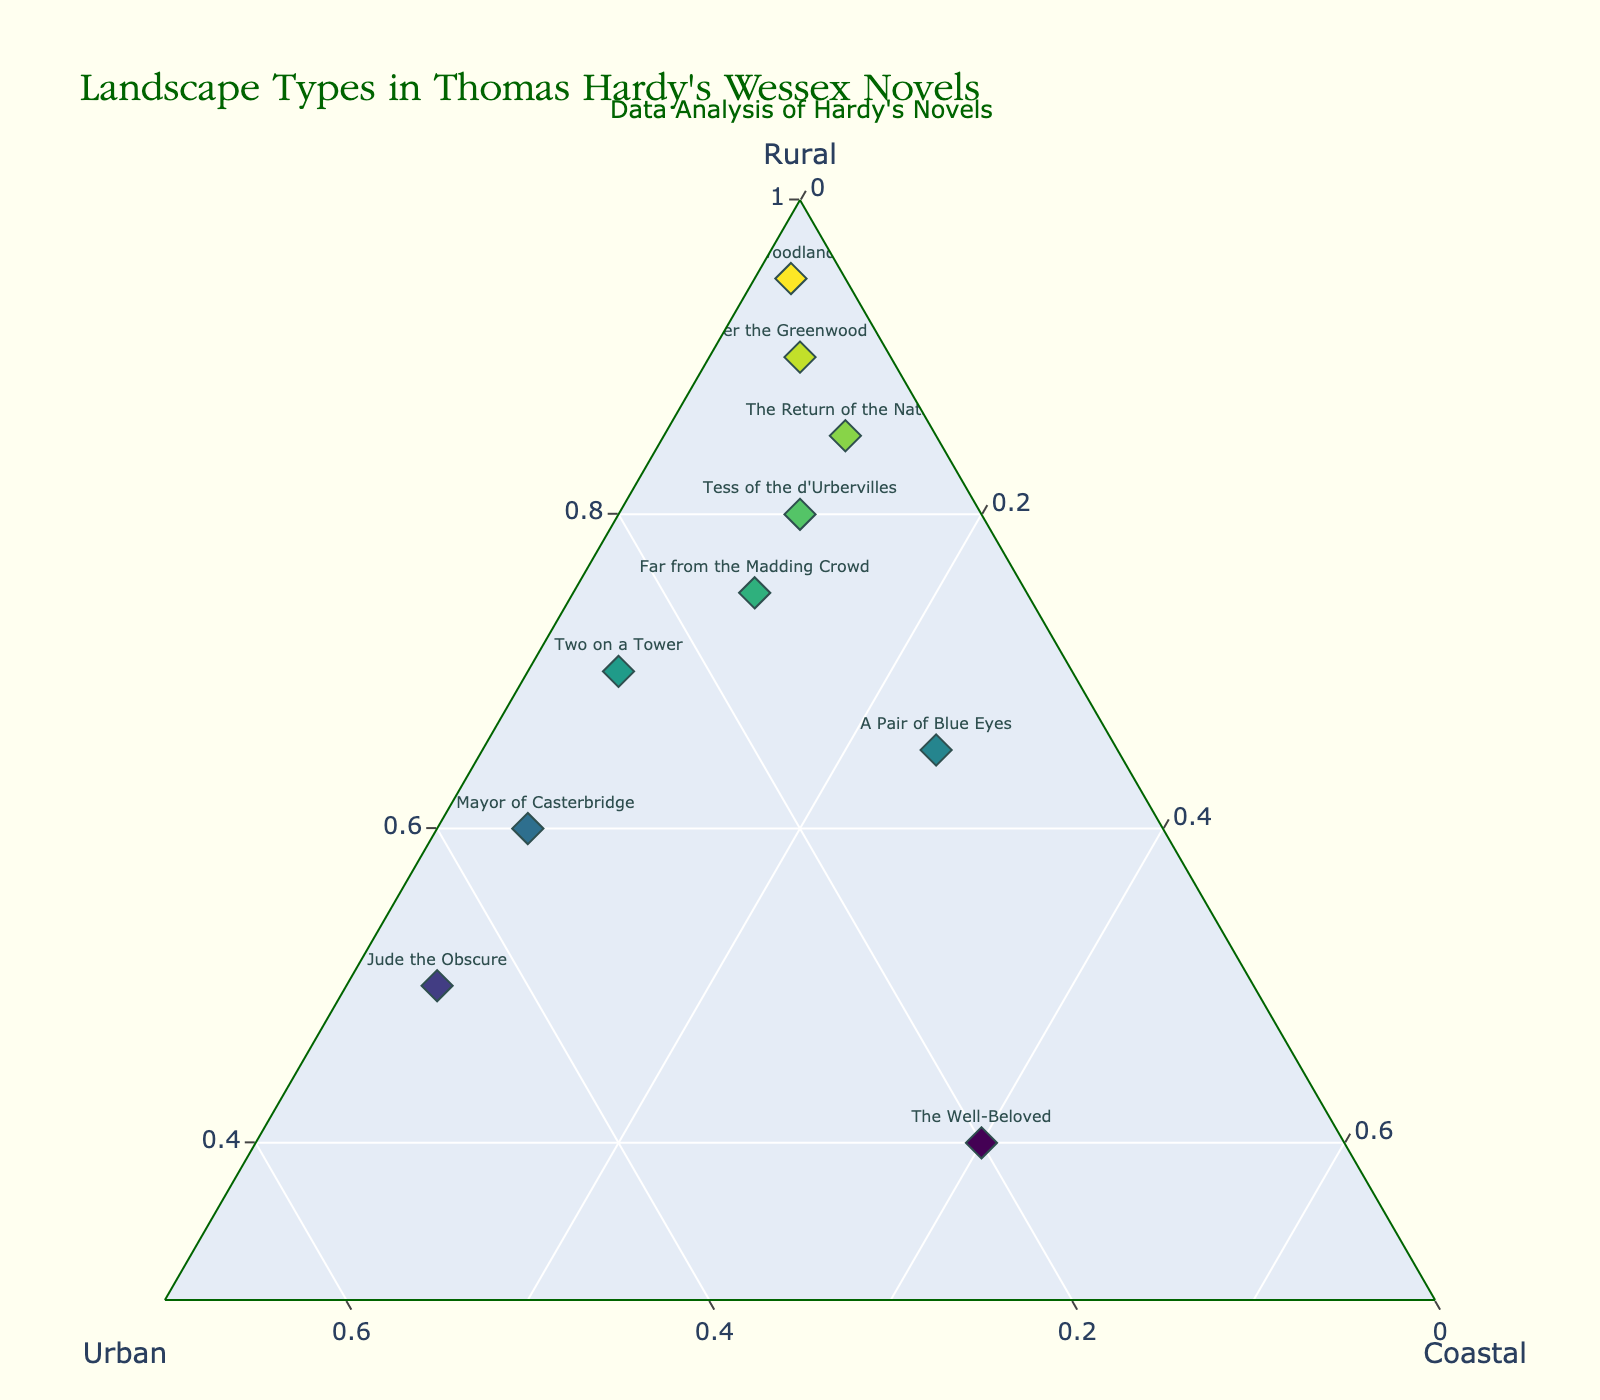What's the title of the plot? The title of the plot is large and centered at the top. It's written in a specific font that suggests it's the title.
Answer: Landscape Types in Thomas Hardy's Wessex Novels How many novels are plotted in the Ternary Plot? By counting the number of distinct text labels (novel titles) on the plot, we can determine how many novels are represented.
Answer: 10 Which novel has the highest rural proportion? Look for the point that is closest to the vertex labeled "Rural," which indicates the highest proportion for that category.
Answer: The Woodlanders Which novel is closest to having an equal distribution of all three landscape types? Identify the novel label closest to the center of the plot, which represents an equal spread between rural, urban, and coastal.
Answer: The Well-Beloved How does "Far from the Madding Crowd" compare to "The Return of the Native" in terms of rural landscape proportion? Both novels need to be compared based on their positions relative to the "Rural" axis. Identify the position relative to the "Rural" angle.
Answer: "The Return of the Native" has a higher rural proportion Which novel has the largest urban representation? Check the novel labels nearest to the "Urban" axis to find the one with the highest urban percentage.
Answer: Jude the Obscure How many novels have a coastal component of at least 20%? Look for novels positioned closer to the "Coastal" axis and determine how many have a lover percentage starting at 20% going towards 100%.
Answer: 2 What is the combined rural proportion of "The Mayor of Casterbridge" and "Two on a Tower"? Add the rural proportions of the two novels: 0.60 + 0.70 = 1.30
Answer: 1.30 What is the median rural percentage among the novels? List the rural percentages: 0.75, 0.80, 0.85, 0.50, 0.60, 0.90, 0.95, 0.65, 0.40, 0.70, and find the middle value. Since there are 10 data points, the median is the fifth value when sorted: (0.75, 0.80, 0.85, 0.50, 0.60) when ordered, the median is between the fifth and sixth numbers in sorted order, so it is the average of 0.75 and 0.80: (0.75+0.80)/2 = 0.775
Answer: 0.775 Which novel has the smallest coastal proportion? Find the data point closest to the "Coastal" vertex to identify the smallest proportion.
Answer: The Woodlanders 